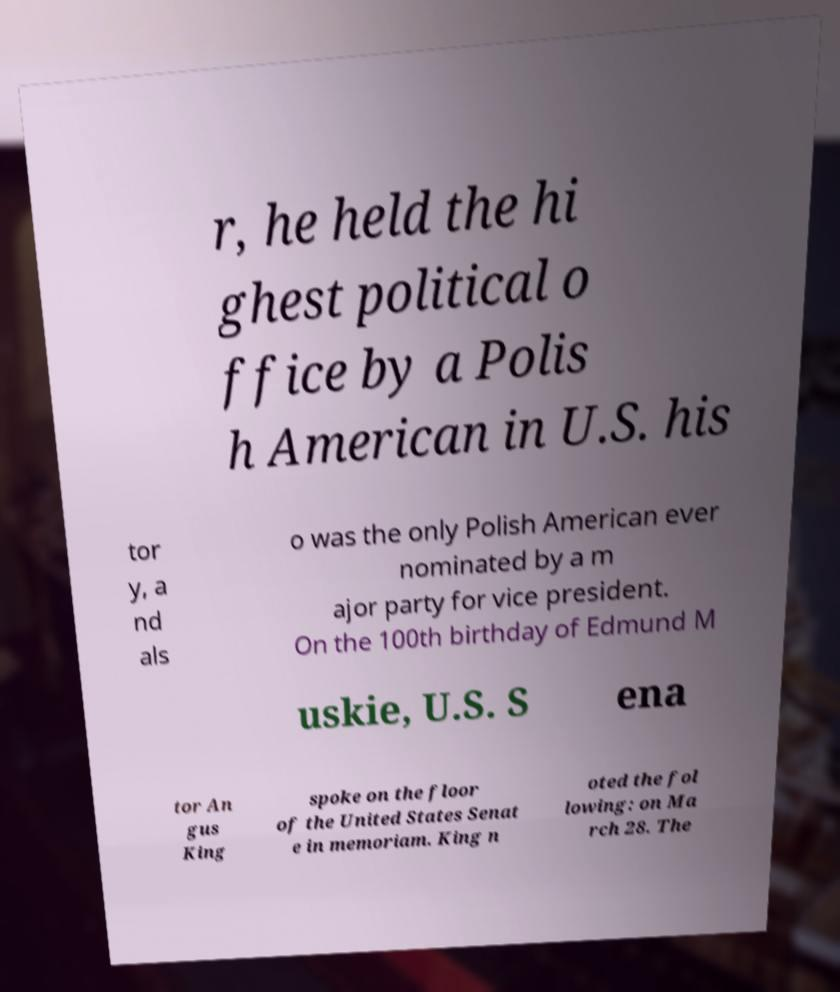Can you read and provide the text displayed in the image?This photo seems to have some interesting text. Can you extract and type it out for me? r, he held the hi ghest political o ffice by a Polis h American in U.S. his tor y, a nd als o was the only Polish American ever nominated by a m ajor party for vice president. On the 100th birthday of Edmund M uskie, U.S. S ena tor An gus King spoke on the floor of the United States Senat e in memoriam. King n oted the fol lowing: on Ma rch 28. The 